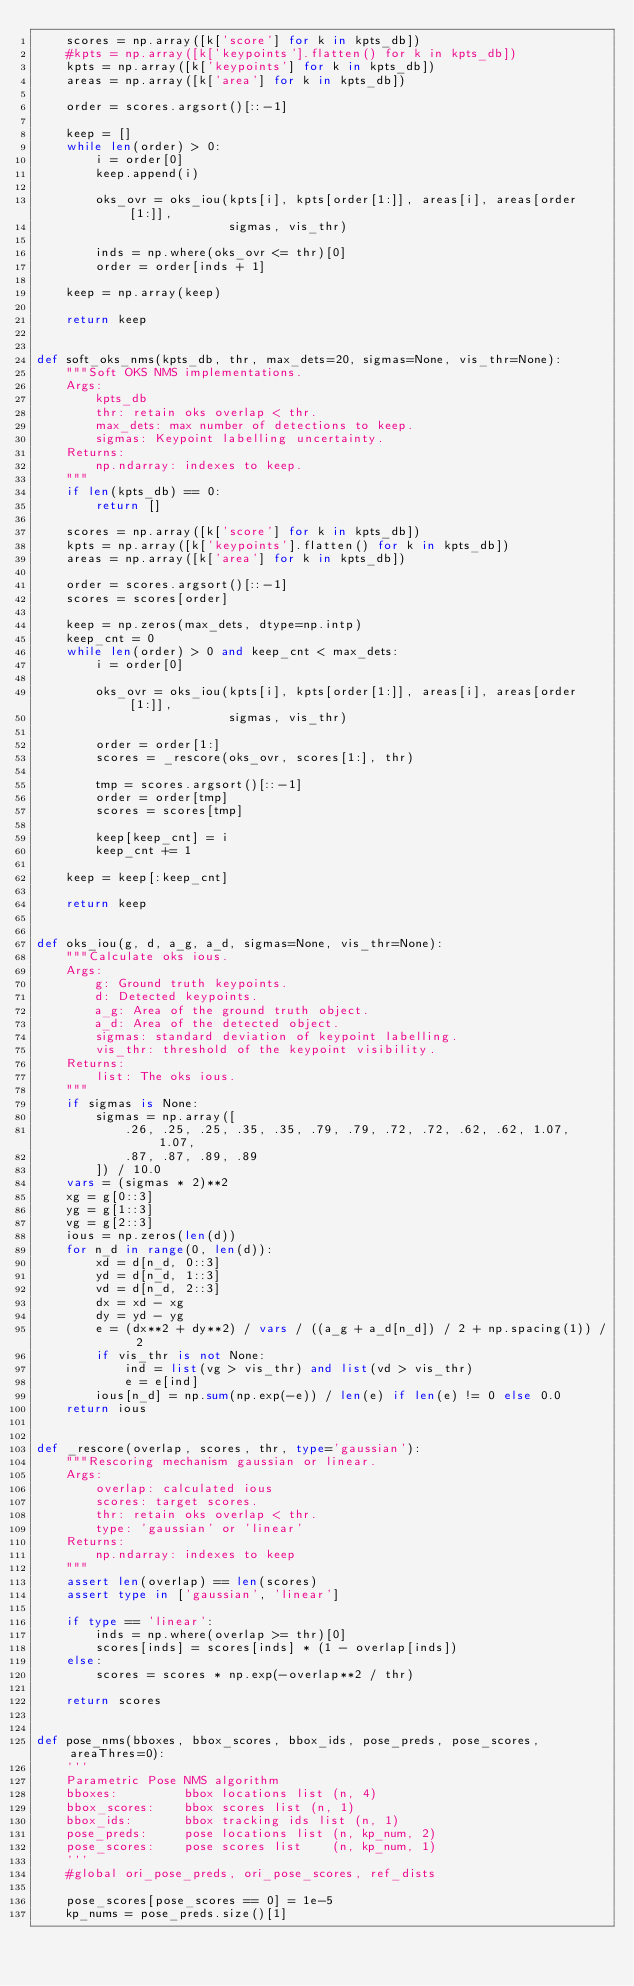Convert code to text. <code><loc_0><loc_0><loc_500><loc_500><_Python_>    scores = np.array([k['score'] for k in kpts_db])
    #kpts = np.array([k['keypoints'].flatten() for k in kpts_db])
    kpts = np.array([k['keypoints'] for k in kpts_db])
    areas = np.array([k['area'] for k in kpts_db])

    order = scores.argsort()[::-1]

    keep = []
    while len(order) > 0:
        i = order[0]
        keep.append(i)

        oks_ovr = oks_iou(kpts[i], kpts[order[1:]], areas[i], areas[order[1:]],
                          sigmas, vis_thr)

        inds = np.where(oks_ovr <= thr)[0]
        order = order[inds + 1]

    keep = np.array(keep)

    return keep


def soft_oks_nms(kpts_db, thr, max_dets=20, sigmas=None, vis_thr=None):
    """Soft OKS NMS implementations.
    Args:
        kpts_db
        thr: retain oks overlap < thr.
        max_dets: max number of detections to keep.
        sigmas: Keypoint labelling uncertainty.
    Returns:
        np.ndarray: indexes to keep.
    """
    if len(kpts_db) == 0:
        return []

    scores = np.array([k['score'] for k in kpts_db])
    kpts = np.array([k['keypoints'].flatten() for k in kpts_db])
    areas = np.array([k['area'] for k in kpts_db])

    order = scores.argsort()[::-1]
    scores = scores[order]

    keep = np.zeros(max_dets, dtype=np.intp)
    keep_cnt = 0
    while len(order) > 0 and keep_cnt < max_dets:
        i = order[0]

        oks_ovr = oks_iou(kpts[i], kpts[order[1:]], areas[i], areas[order[1:]],
                          sigmas, vis_thr)

        order = order[1:]
        scores = _rescore(oks_ovr, scores[1:], thr)

        tmp = scores.argsort()[::-1]
        order = order[tmp]
        scores = scores[tmp]

        keep[keep_cnt] = i
        keep_cnt += 1

    keep = keep[:keep_cnt]

    return keep


def oks_iou(g, d, a_g, a_d, sigmas=None, vis_thr=None):
    """Calculate oks ious.
    Args:
        g: Ground truth keypoints.
        d: Detected keypoints.
        a_g: Area of the ground truth object.
        a_d: Area of the detected object.
        sigmas: standard deviation of keypoint labelling.
        vis_thr: threshold of the keypoint visibility.
    Returns:
        list: The oks ious.
    """
    if sigmas is None:
        sigmas = np.array([
            .26, .25, .25, .35, .35, .79, .79, .72, .72, .62, .62, 1.07, 1.07,
            .87, .87, .89, .89
        ]) / 10.0
    vars = (sigmas * 2)**2
    xg = g[0::3]
    yg = g[1::3]
    vg = g[2::3]
    ious = np.zeros(len(d))
    for n_d in range(0, len(d)):
        xd = d[n_d, 0::3]
        yd = d[n_d, 1::3]
        vd = d[n_d, 2::3]
        dx = xd - xg
        dy = yd - yg
        e = (dx**2 + dy**2) / vars / ((a_g + a_d[n_d]) / 2 + np.spacing(1)) / 2
        if vis_thr is not None:
            ind = list(vg > vis_thr) and list(vd > vis_thr)
            e = e[ind]
        ious[n_d] = np.sum(np.exp(-e)) / len(e) if len(e) != 0 else 0.0
    return ious


def _rescore(overlap, scores, thr, type='gaussian'):
    """Rescoring mechanism gaussian or linear.
    Args:
        overlap: calculated ious
        scores: target scores.
        thr: retain oks overlap < thr.
        type: 'gaussian' or 'linear'
    Returns:
        np.ndarray: indexes to keep
    """
    assert len(overlap) == len(scores)
    assert type in ['gaussian', 'linear']

    if type == 'linear':
        inds = np.where(overlap >= thr)[0]
        scores[inds] = scores[inds] * (1 - overlap[inds])
    else:
        scores = scores * np.exp(-overlap**2 / thr)

    return scores


def pose_nms(bboxes, bbox_scores, bbox_ids, pose_preds, pose_scores, areaThres=0):
    '''
    Parametric Pose NMS algorithm
    bboxes:         bbox locations list (n, 4)
    bbox_scores:    bbox scores list (n, 1)
    bbox_ids:       bbox tracking ids list (n, 1)
    pose_preds:     pose locations list (n, kp_num, 2)
    pose_scores:    pose scores list    (n, kp_num, 1)
    '''
    #global ori_pose_preds, ori_pose_scores, ref_dists

    pose_scores[pose_scores == 0] = 1e-5
    kp_nums = pose_preds.size()[1]</code> 